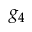Convert formula to latex. <formula><loc_0><loc_0><loc_500><loc_500>g _ { 4 }</formula> 